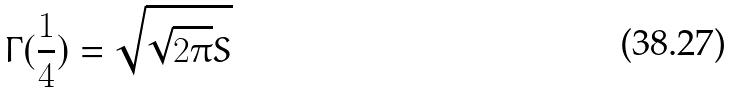Convert formula to latex. <formula><loc_0><loc_0><loc_500><loc_500>\Gamma ( \frac { 1 } { 4 } ) = \sqrt { \sqrt { 2 \pi } S }</formula> 